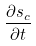Convert formula to latex. <formula><loc_0><loc_0><loc_500><loc_500>\frac { \partial s _ { c } } { \partial t }</formula> 